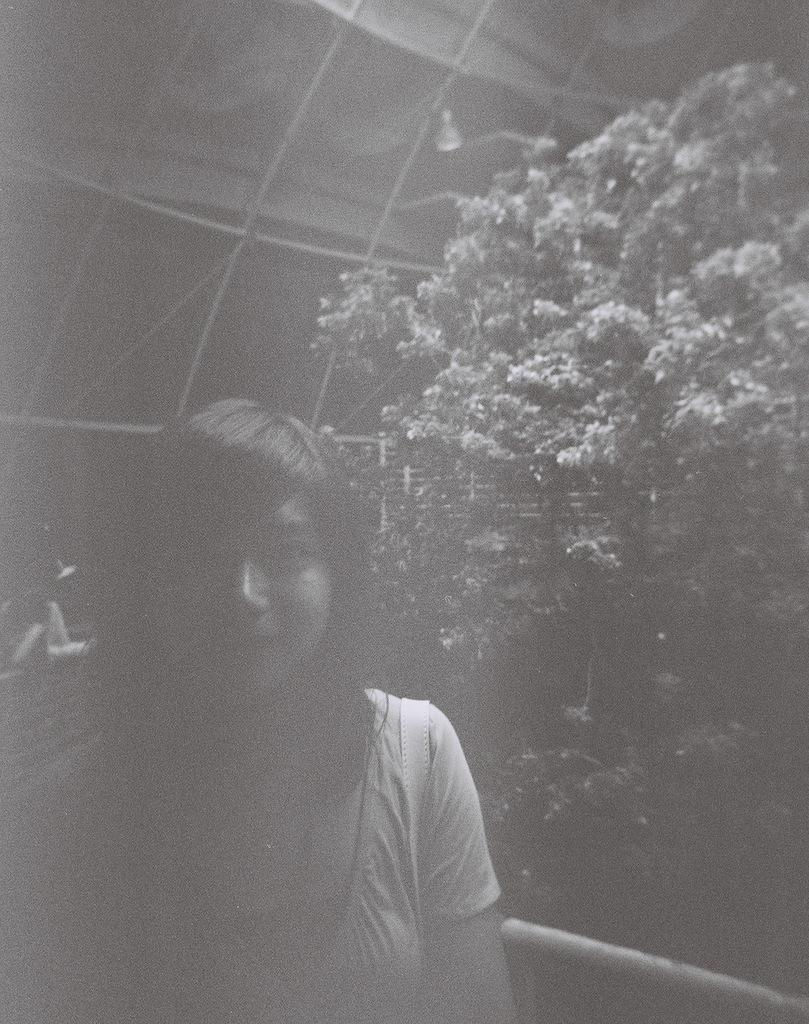Who is present in the image? There is a woman in the picture. What is the woman doing in the image? The woman is standing in the image. What expression does the woman have in the image? The woman is smiling in the image. What can be seen in the background of the picture? There is a tree in the background of the picture. How many snails are crawling on the woman's knee in the image? There are no snails present in the image, and the woman's knee is not visible. 